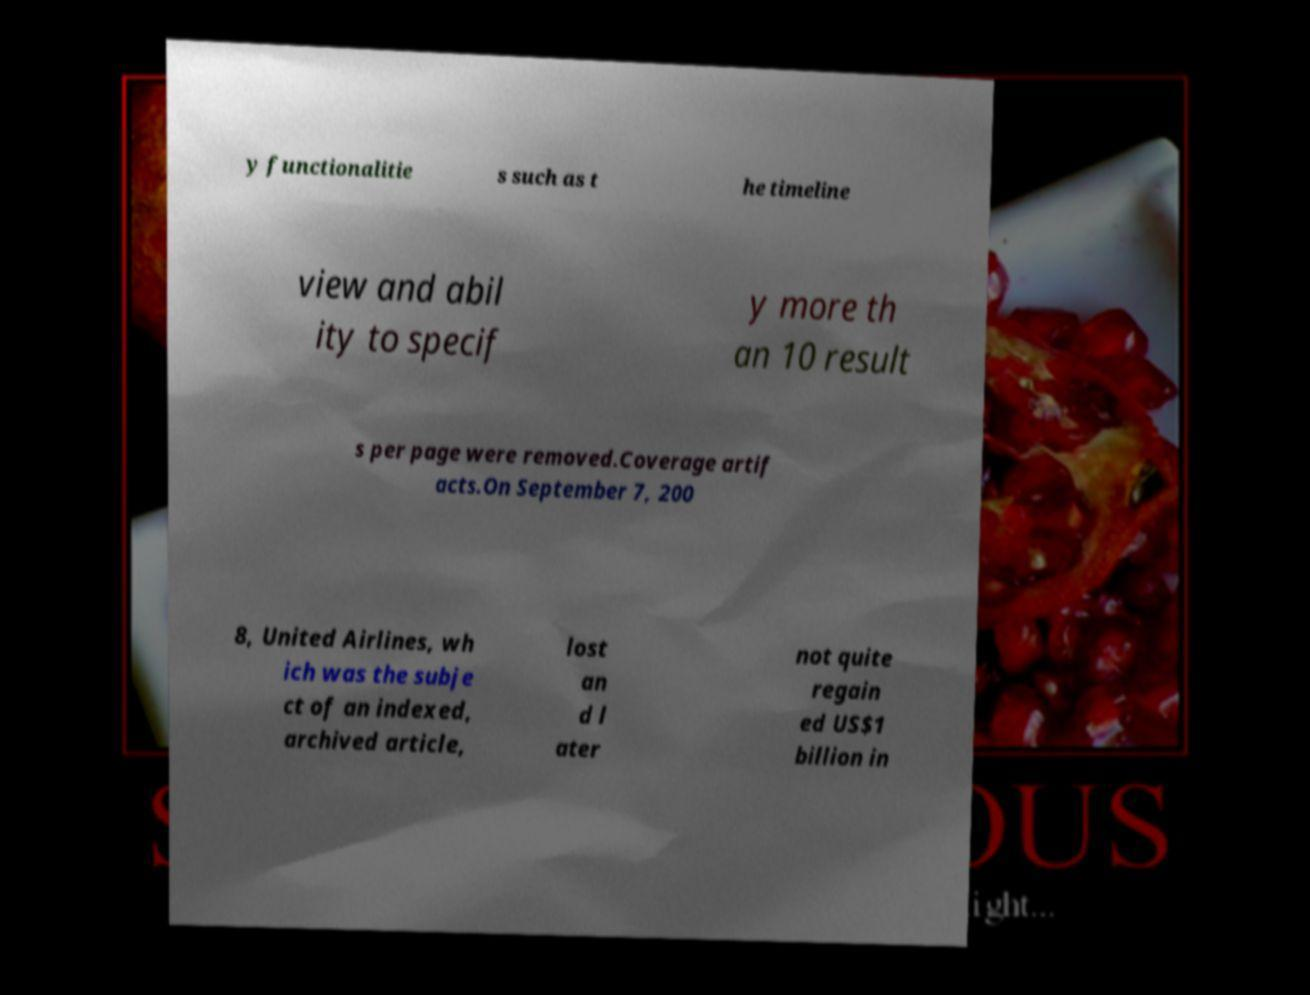Can you read and provide the text displayed in the image?This photo seems to have some interesting text. Can you extract and type it out for me? y functionalitie s such as t he timeline view and abil ity to specif y more th an 10 result s per page were removed.Coverage artif acts.On September 7, 200 8, United Airlines, wh ich was the subje ct of an indexed, archived article, lost an d l ater not quite regain ed US$1 billion in 